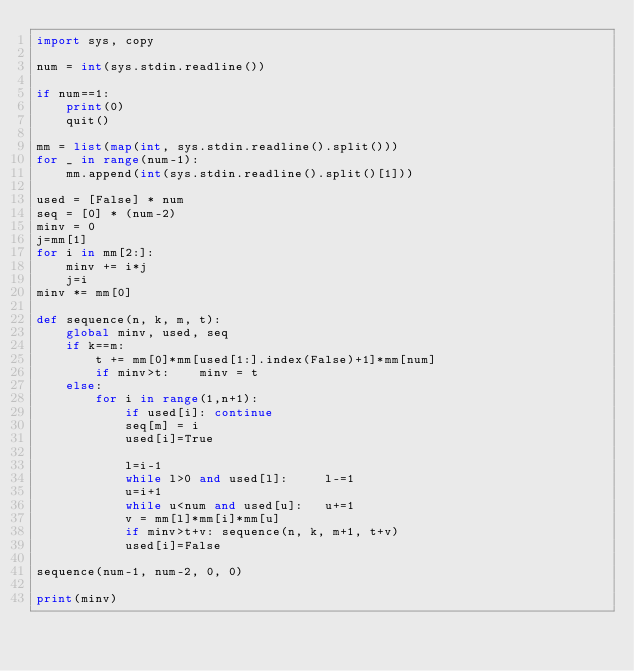Convert code to text. <code><loc_0><loc_0><loc_500><loc_500><_Python_>import sys, copy

num = int(sys.stdin.readline())

if num==1:
    print(0)
    quit()
    
mm = list(map(int, sys.stdin.readline().split()))
for _ in range(num-1):
    mm.append(int(sys.stdin.readline().split()[1]))

used = [False] * num
seq = [0] * (num-2)
minv = 0
j=mm[1]
for i in mm[2:]:
    minv += i*j
    j=i
minv *= mm[0]    

def sequence(n, k, m, t):
    global minv, used, seq
    if k==m:
        t += mm[0]*mm[used[1:].index(False)+1]*mm[num]
        if minv>t:    minv = t
    else:
        for i in range(1,n+1):
            if used[i]: continue
            seq[m] = i
            used[i]=True

            l=i-1
            while l>0 and used[l]:     l-=1
            u=i+1
            while u<num and used[u]:   u+=1
            v = mm[l]*mm[i]*mm[u]
            if minv>t+v: sequence(n, k, m+1, t+v)
            used[i]=False

sequence(num-1, num-2, 0, 0)

print(minv)
</code> 